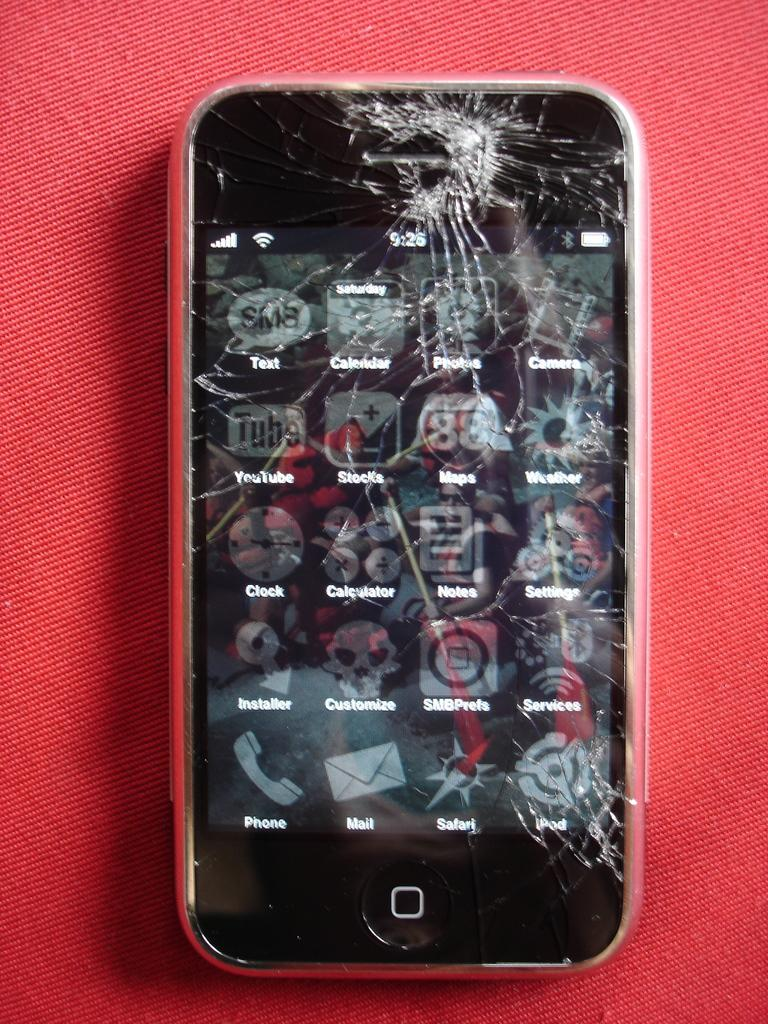<image>
Render a clear and concise summary of the photo. A smashed phone screen where you can make out several aps, including phone, mail, safari, clock,etc. 